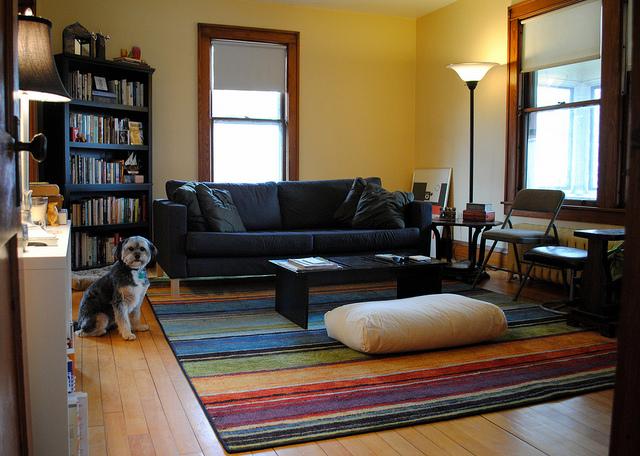What is foldable next to the window?
Keep it brief. Chair. What color is the area rug?
Give a very brief answer. Multi. What is the animal doing?
Quick response, please. Sitting. How many pillows on the couch?
Be succinct. 4. 